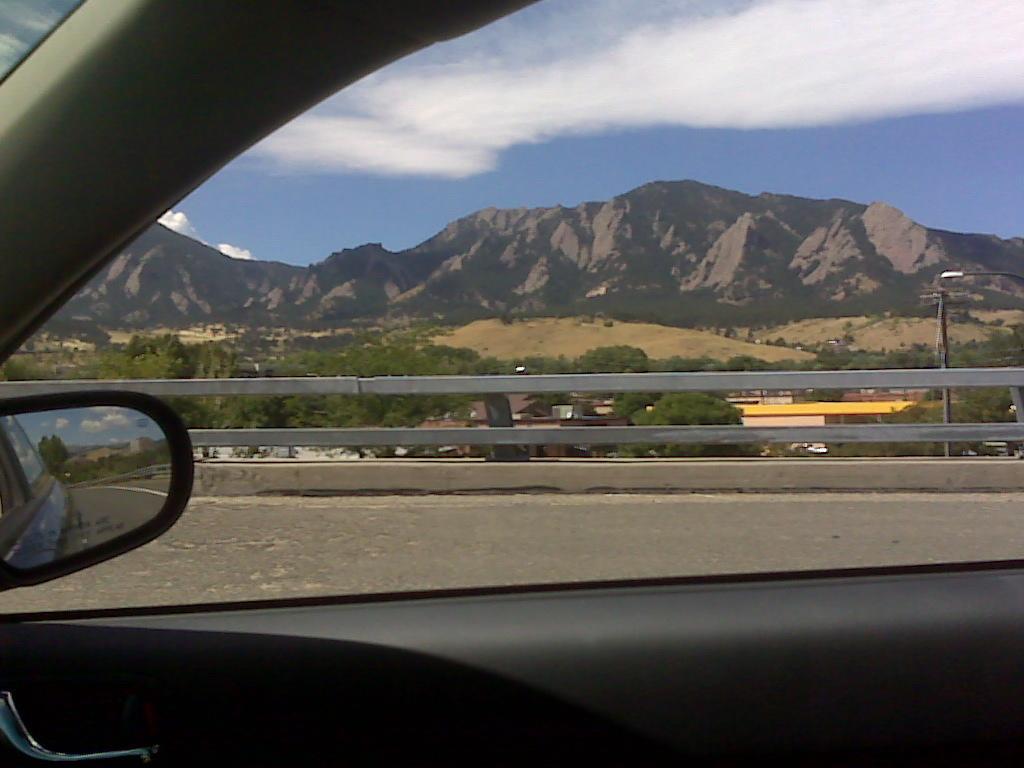How would you summarize this image in a sentence or two? The image is captured from inside a car, behind the window there are mountains, trees and a road. 